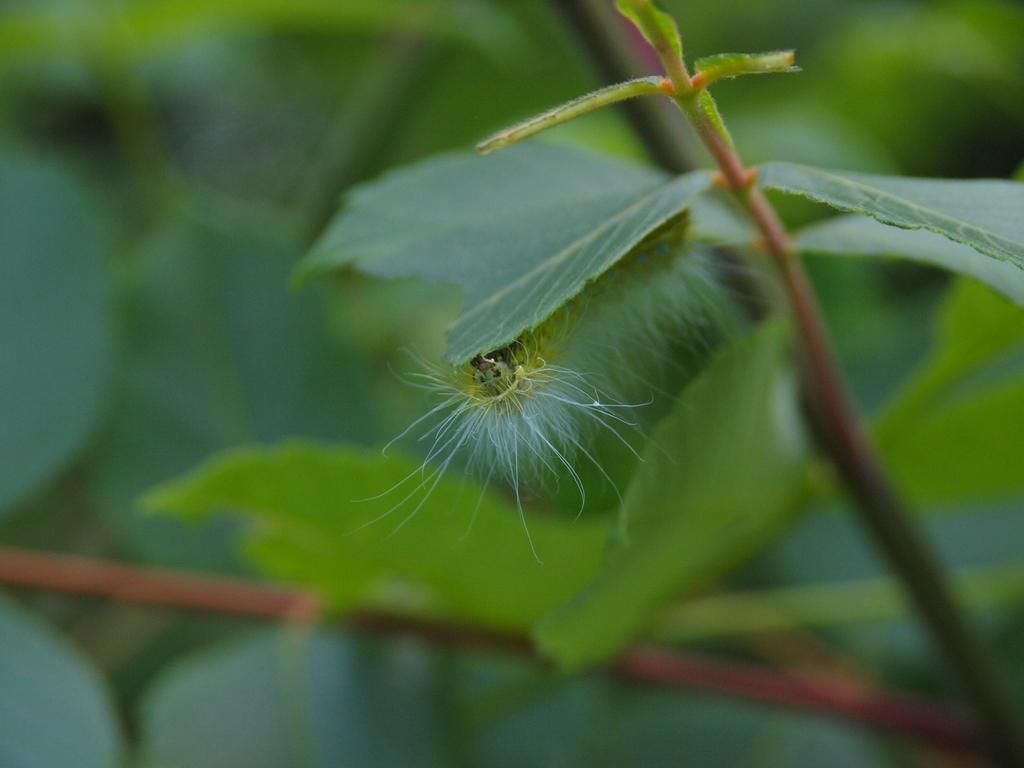Can you describe this image briefly? In this image I can see an insect which is green, black and white in color is under a leaf which is green in color. I can see a plant which is green and red in color. I can see the blurry background which is green in color. 